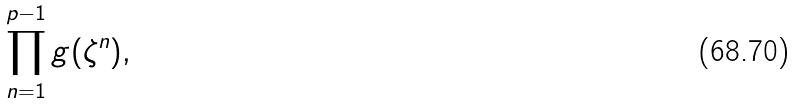<formula> <loc_0><loc_0><loc_500><loc_500>\prod _ { n = 1 } ^ { p - 1 } g ( \zeta ^ { n } ) ,</formula> 